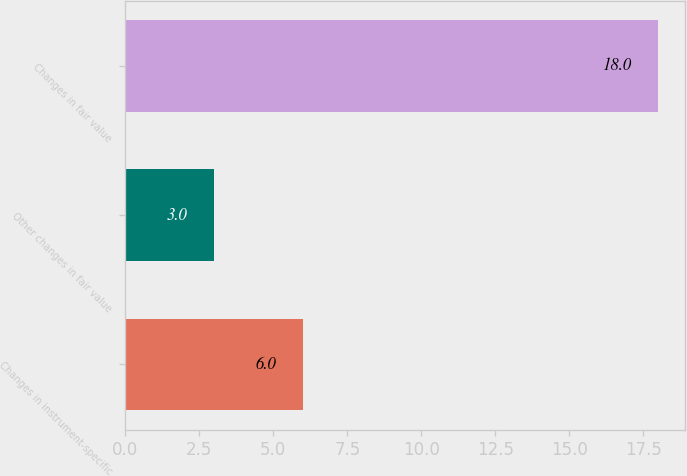<chart> <loc_0><loc_0><loc_500><loc_500><bar_chart><fcel>Changes in instrument-specific<fcel>Other changes in fair value<fcel>Changes in fair value<nl><fcel>6<fcel>3<fcel>18<nl></chart> 